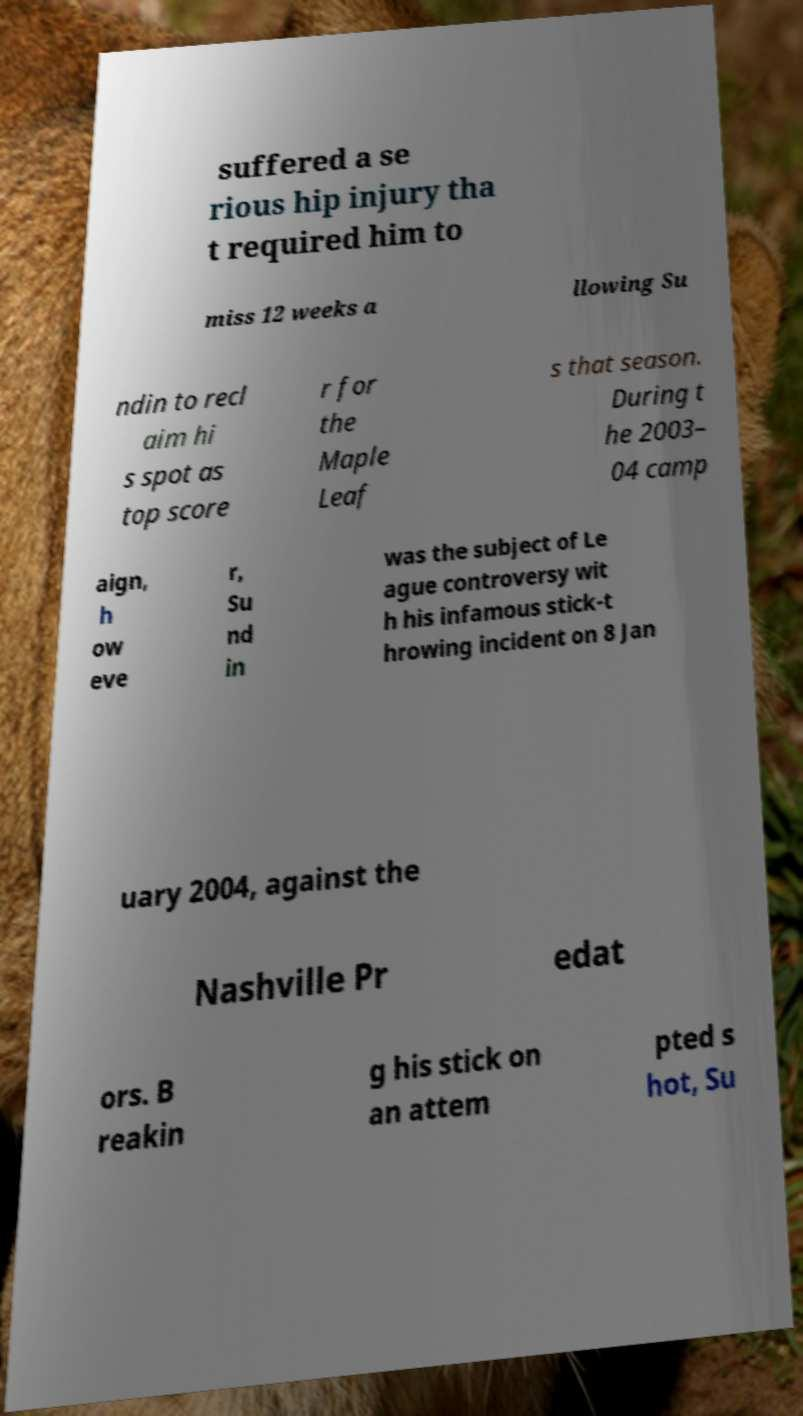Please read and relay the text visible in this image. What does it say? suffered a se rious hip injury tha t required him to miss 12 weeks a llowing Su ndin to recl aim hi s spot as top score r for the Maple Leaf s that season. During t he 2003– 04 camp aign, h ow eve r, Su nd in was the subject of Le ague controversy wit h his infamous stick-t hrowing incident on 8 Jan uary 2004, against the Nashville Pr edat ors. B reakin g his stick on an attem pted s hot, Su 